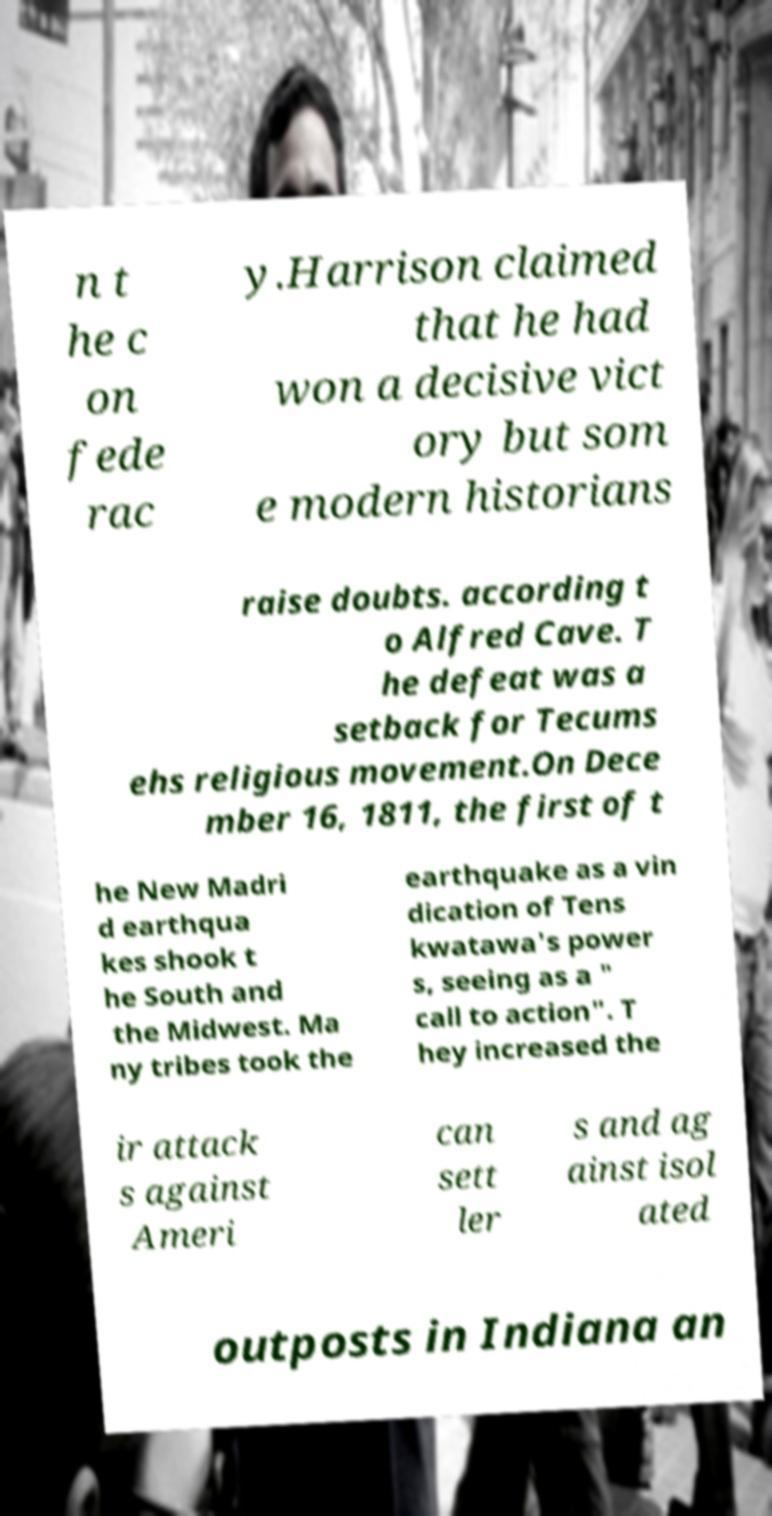I need the written content from this picture converted into text. Can you do that? n t he c on fede rac y.Harrison claimed that he had won a decisive vict ory but som e modern historians raise doubts. according t o Alfred Cave. T he defeat was a setback for Tecums ehs religious movement.On Dece mber 16, 1811, the first of t he New Madri d earthqua kes shook t he South and the Midwest. Ma ny tribes took the earthquake as a vin dication of Tens kwatawa's power s, seeing as a " call to action". T hey increased the ir attack s against Ameri can sett ler s and ag ainst isol ated outposts in Indiana an 